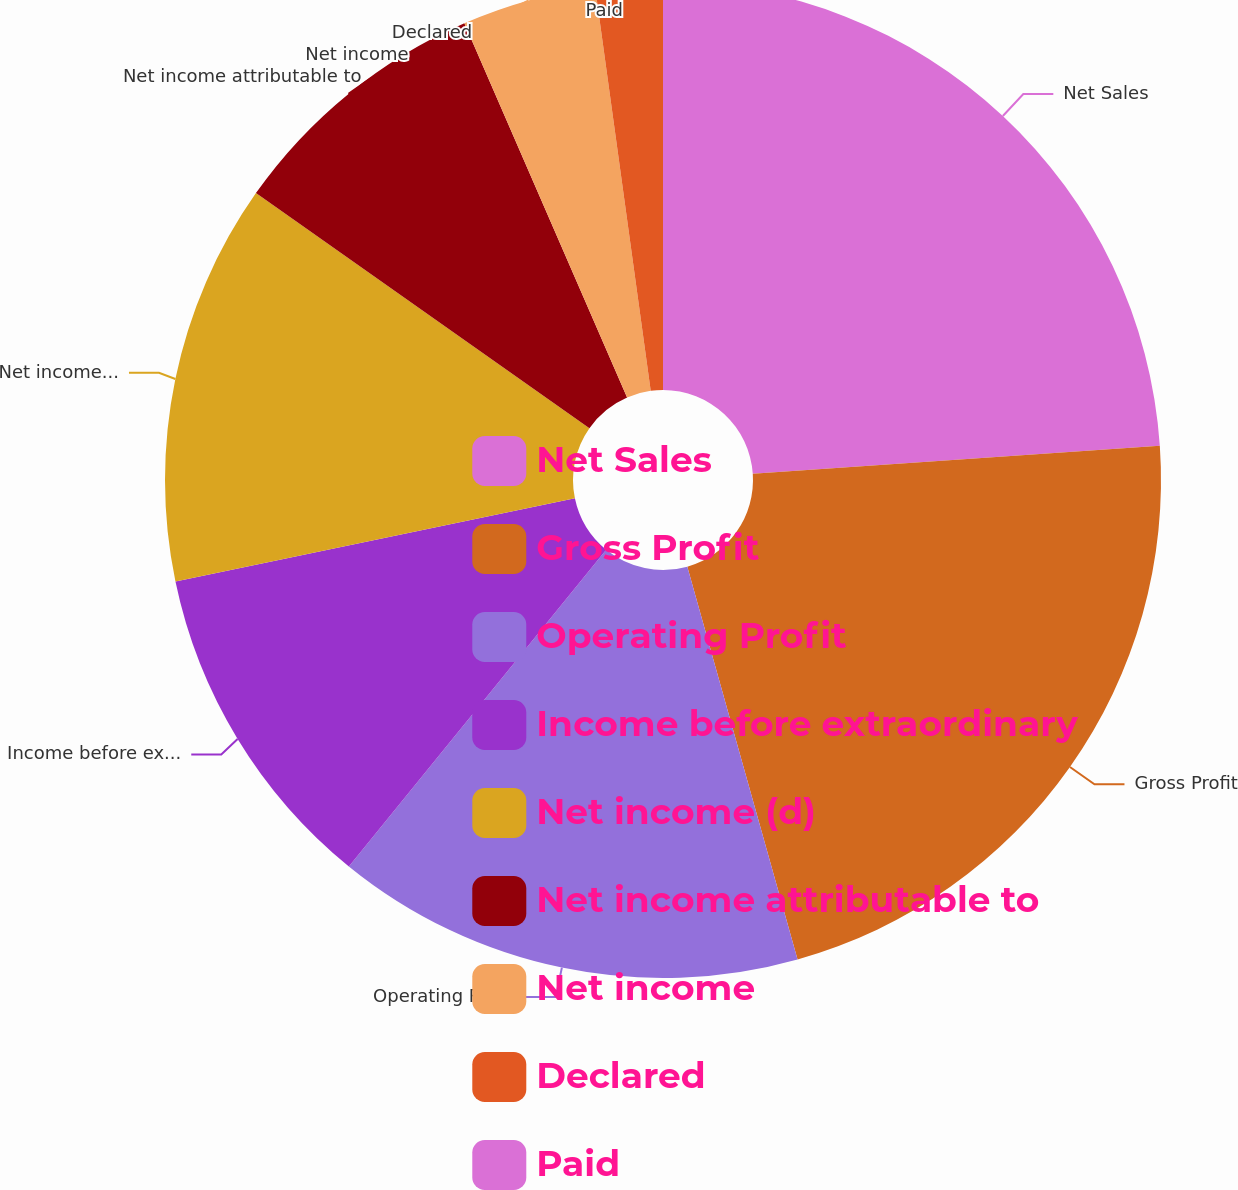<chart> <loc_0><loc_0><loc_500><loc_500><pie_chart><fcel>Net Sales<fcel>Gross Profit<fcel>Operating Profit<fcel>Income before extraordinary<fcel>Net income (d)<fcel>Net income attributable to<fcel>Net income<fcel>Declared<fcel>Paid<nl><fcel>23.91%<fcel>21.74%<fcel>15.22%<fcel>10.87%<fcel>13.04%<fcel>8.7%<fcel>4.35%<fcel>2.18%<fcel>0.0%<nl></chart> 